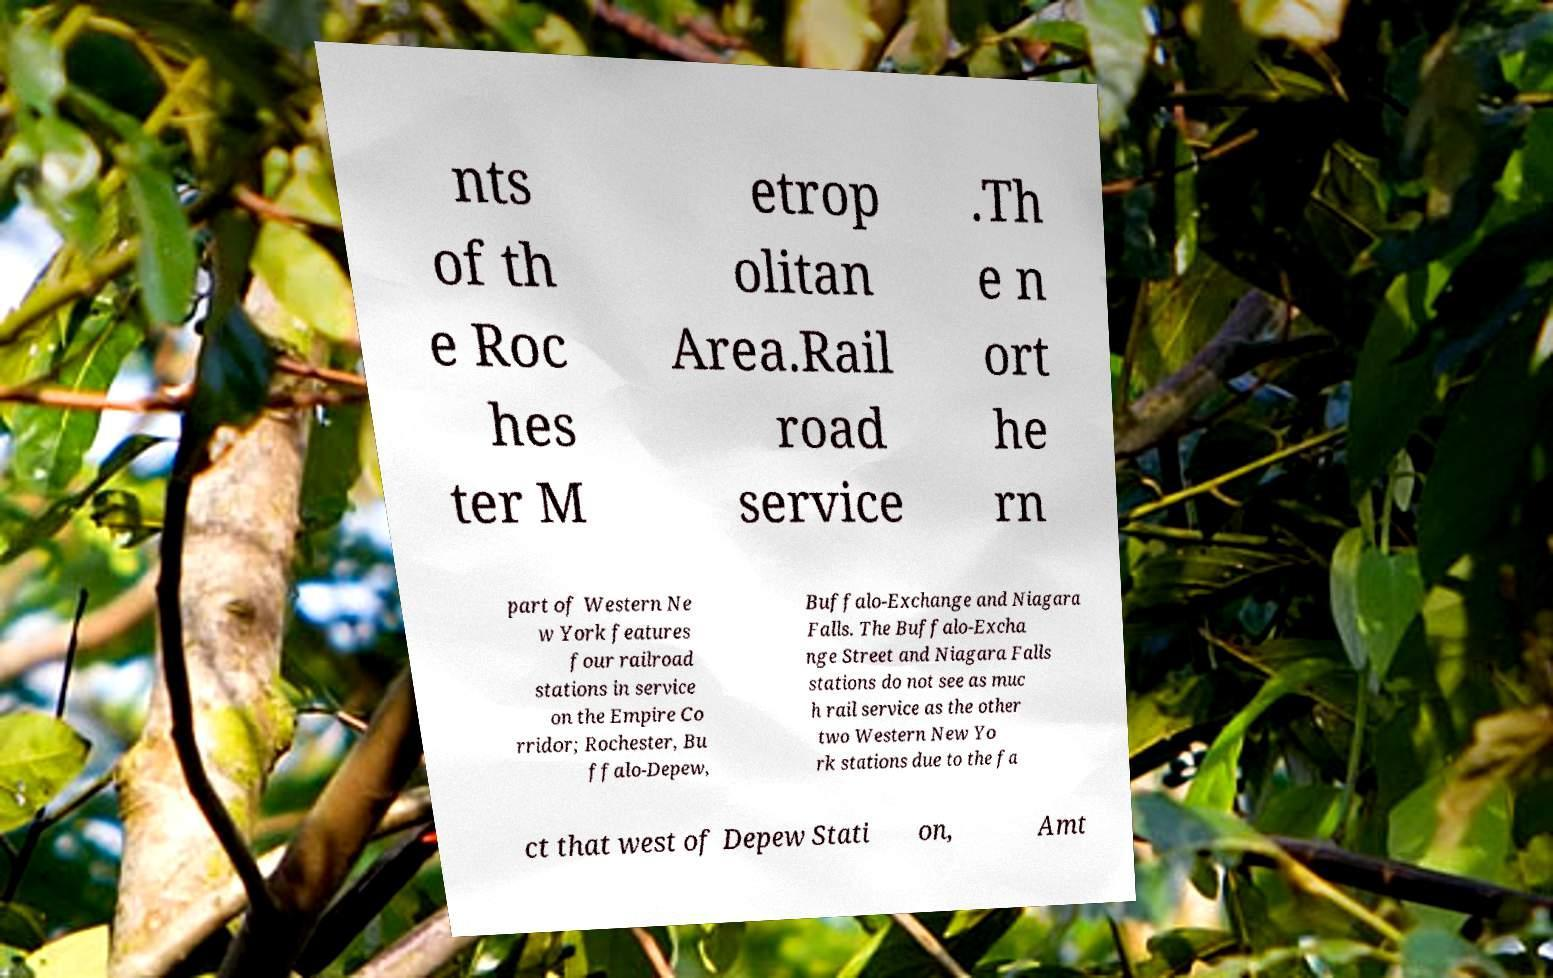Please identify and transcribe the text found in this image. nts of th e Roc hes ter M etrop olitan Area.Rail road service .Th e n ort he rn part of Western Ne w York features four railroad stations in service on the Empire Co rridor; Rochester, Bu ffalo-Depew, Buffalo-Exchange and Niagara Falls. The Buffalo-Excha nge Street and Niagara Falls stations do not see as muc h rail service as the other two Western New Yo rk stations due to the fa ct that west of Depew Stati on, Amt 